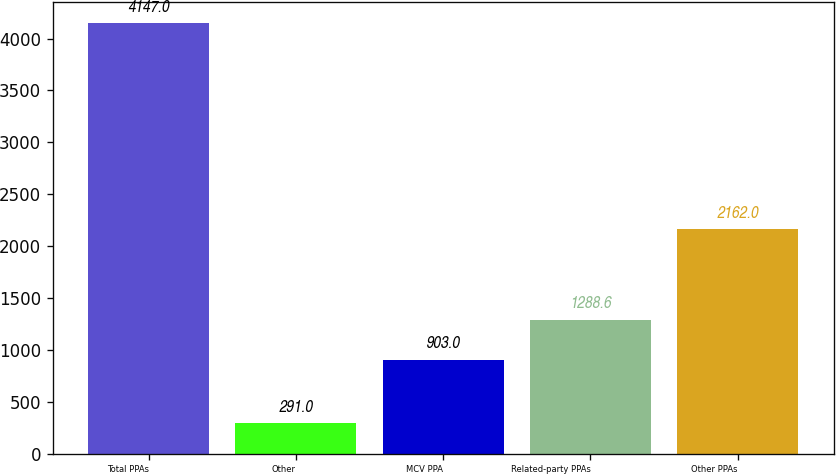<chart> <loc_0><loc_0><loc_500><loc_500><bar_chart><fcel>Total PPAs<fcel>Other<fcel>MCV PPA<fcel>Related-party PPAs<fcel>Other PPAs<nl><fcel>4147<fcel>291<fcel>903<fcel>1288.6<fcel>2162<nl></chart> 